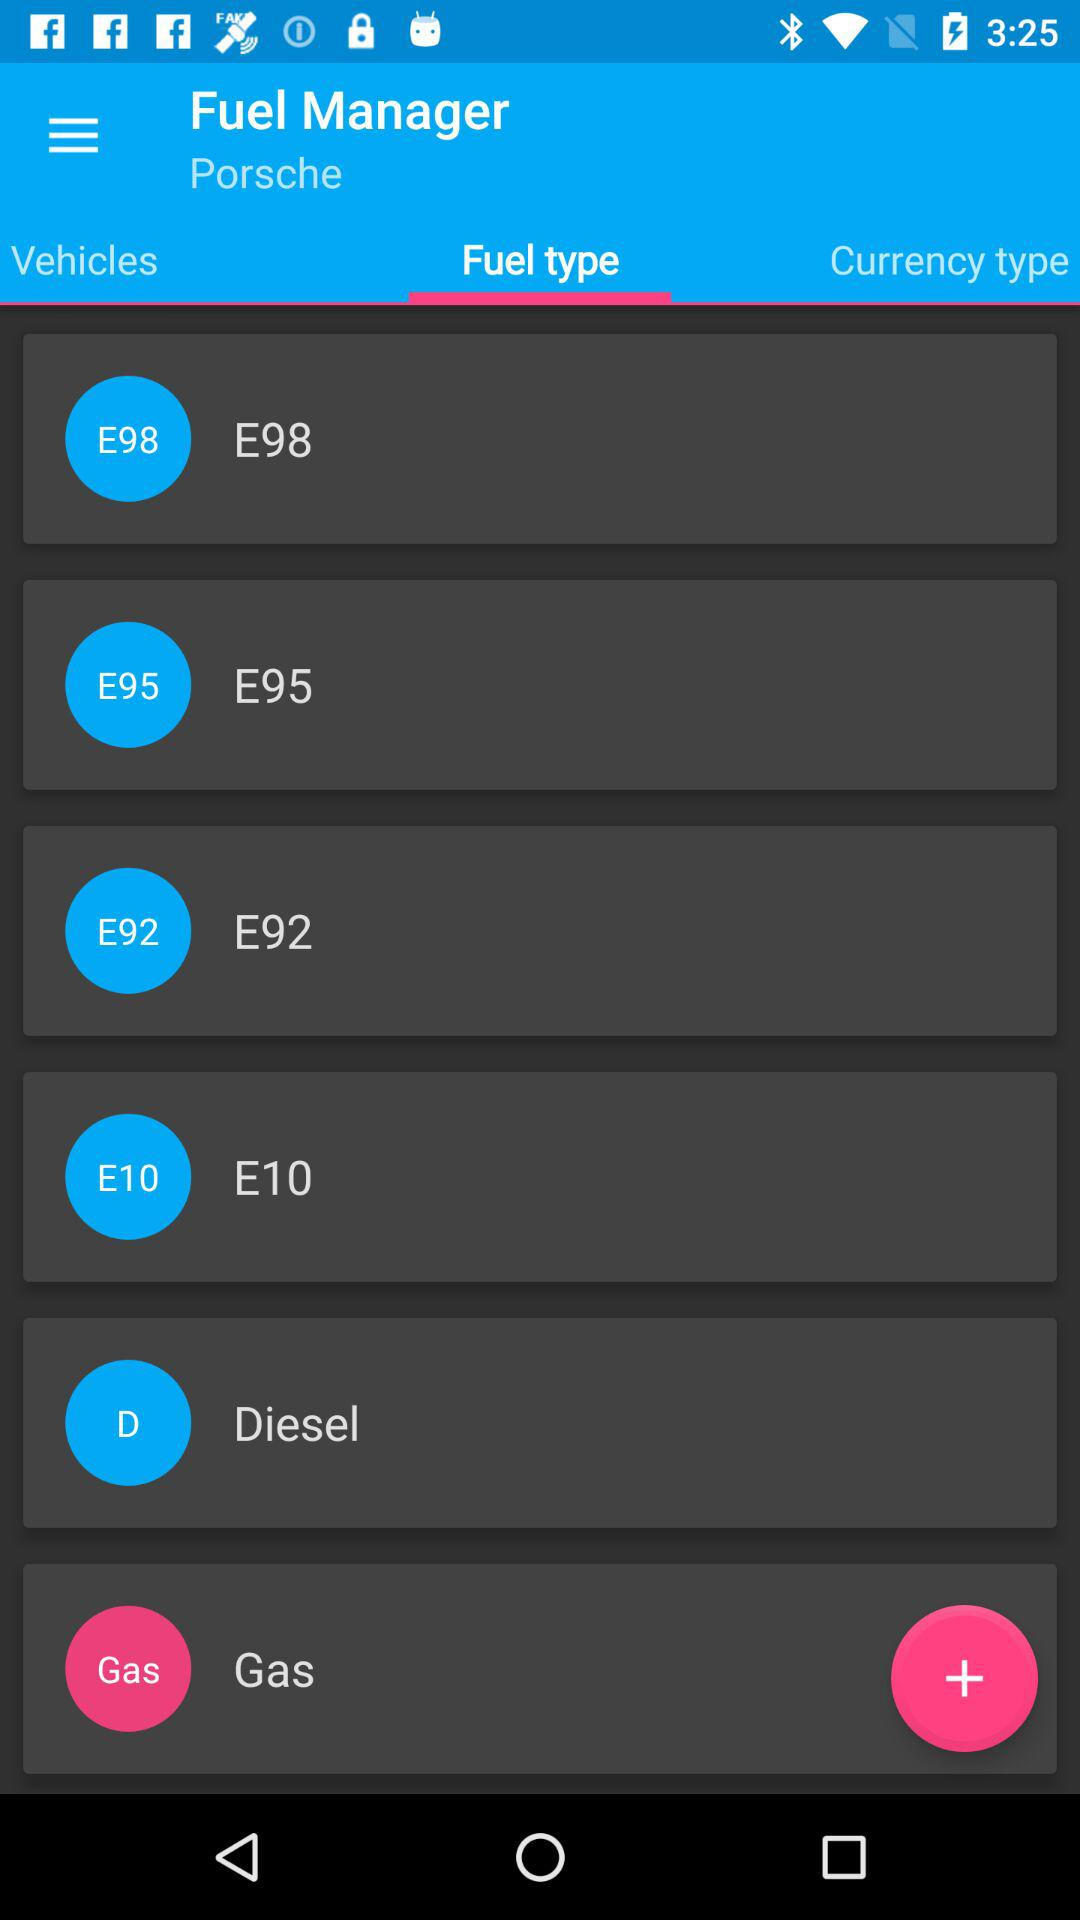What are the types of fuel? The types of fuel are "E98", "E95", "E92", "E10", "Diesel", and "Gas". 